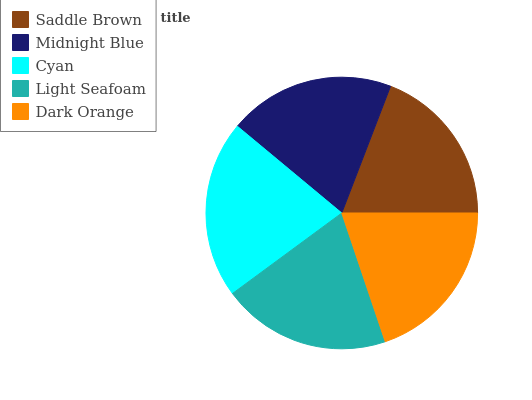Is Saddle Brown the minimum?
Answer yes or no. Yes. Is Cyan the maximum?
Answer yes or no. Yes. Is Midnight Blue the minimum?
Answer yes or no. No. Is Midnight Blue the maximum?
Answer yes or no. No. Is Midnight Blue greater than Saddle Brown?
Answer yes or no. Yes. Is Saddle Brown less than Midnight Blue?
Answer yes or no. Yes. Is Saddle Brown greater than Midnight Blue?
Answer yes or no. No. Is Midnight Blue less than Saddle Brown?
Answer yes or no. No. Is Dark Orange the high median?
Answer yes or no. Yes. Is Dark Orange the low median?
Answer yes or no. Yes. Is Light Seafoam the high median?
Answer yes or no. No. Is Cyan the low median?
Answer yes or no. No. 